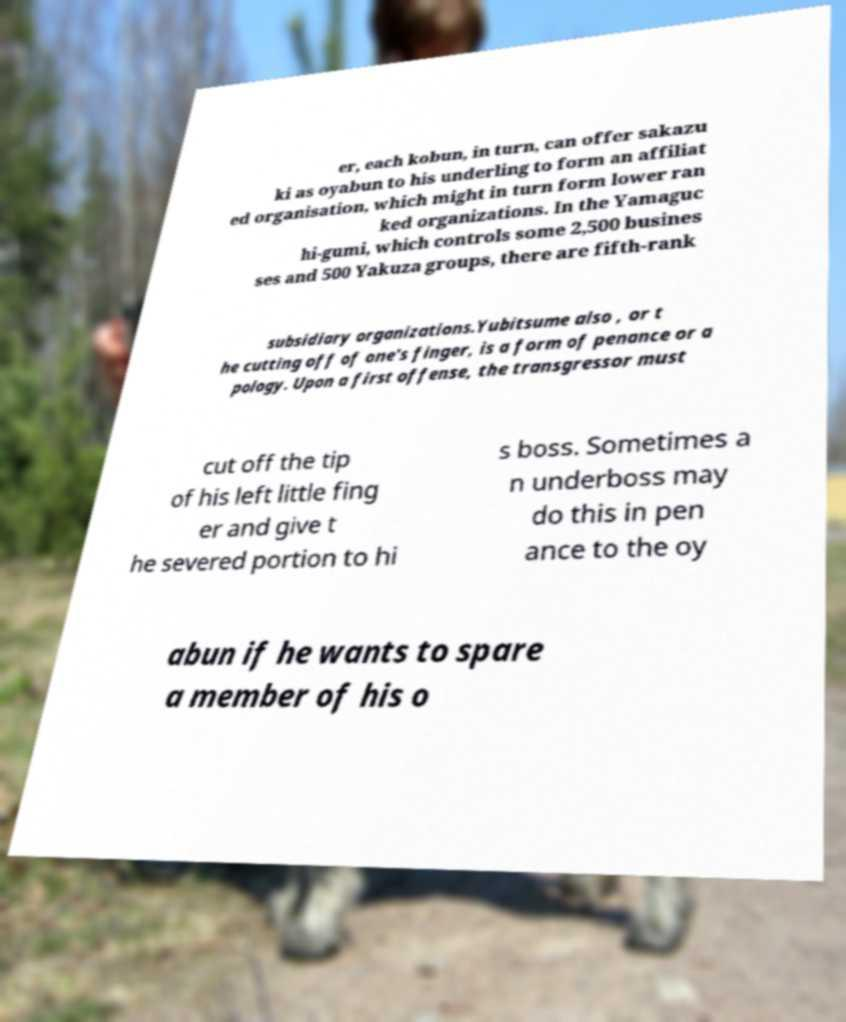I need the written content from this picture converted into text. Can you do that? er, each kobun, in turn, can offer sakazu ki as oyabun to his underling to form an affiliat ed organisation, which might in turn form lower ran ked organizations. In the Yamaguc hi-gumi, which controls some 2,500 busines ses and 500 Yakuza groups, there are fifth-rank subsidiary organizations.Yubitsume also , or t he cutting off of one's finger, is a form of penance or a pology. Upon a first offense, the transgressor must cut off the tip of his left little fing er and give t he severed portion to hi s boss. Sometimes a n underboss may do this in pen ance to the oy abun if he wants to spare a member of his o 